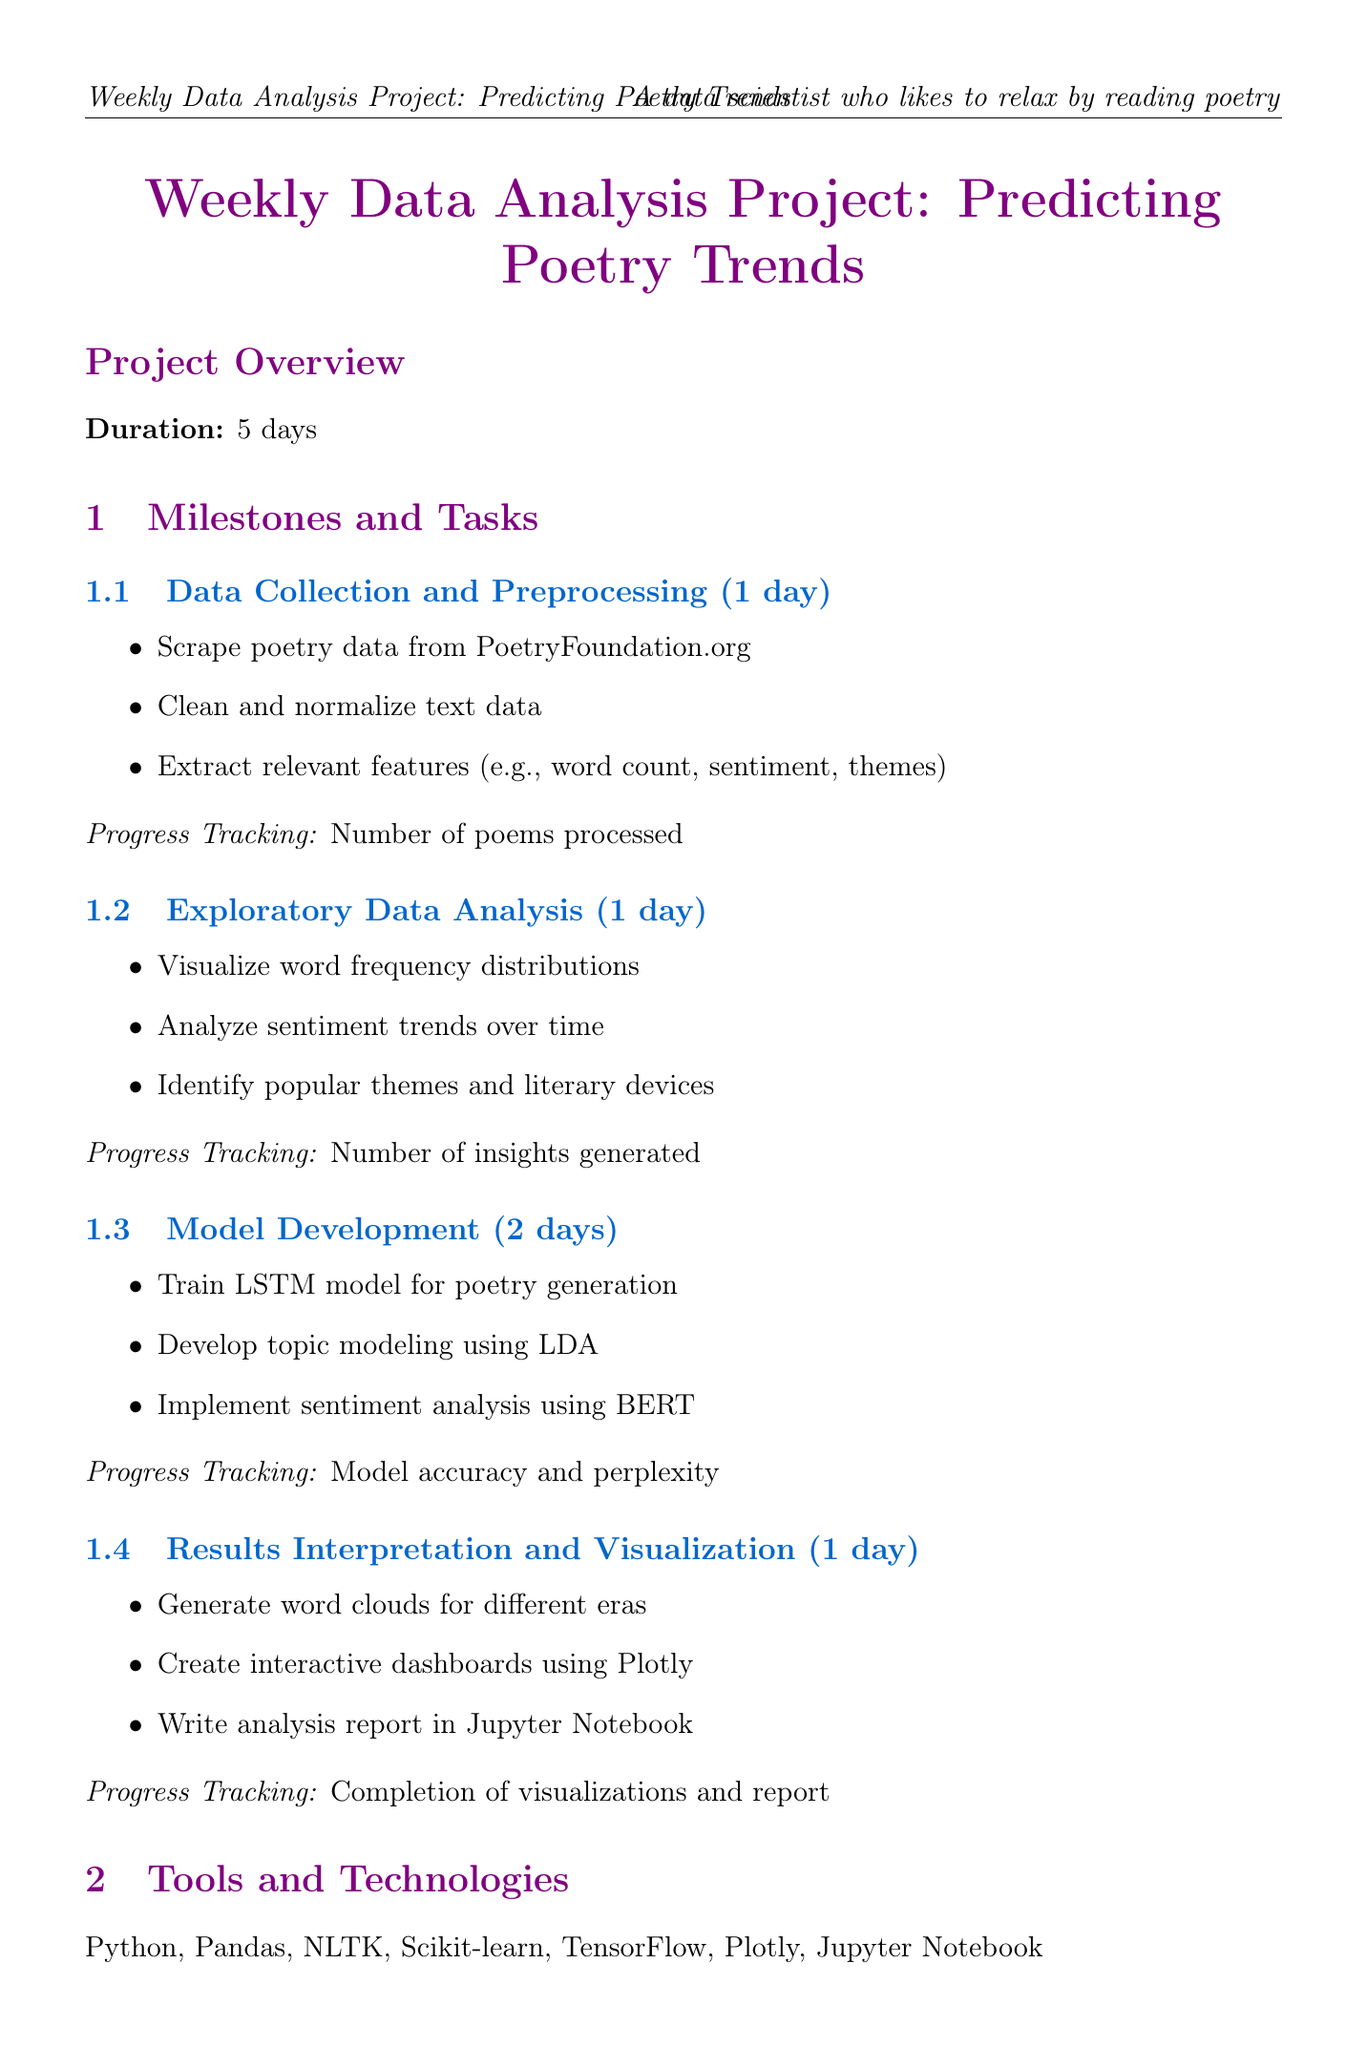What is the project duration? The project duration is specified in the document as 5 days.
Answer: 5 days Who is responsible for model development and poetry analysis? The document lists team members and their responsibilities; Emily Dickinson is assigned to this role.
Answer: Emily Dickinson What is the daily stand-up time? The document explicitly states the daily stand-up time as indicated.
Answer: 9:00 AM How many tasks are listed under Exploratory Data Analysis? The number of tasks in the Exploratory Data Analysis section can be counted from the document.
Answer: 3 tasks What is one potential challenge mentioned in the document? A list of potential challenges is provided, and one can be retrieved as an example.
Answer: Handling archaic language in older poems What technology is used for data visualization? The tools and technologies section lists specific tools; Plotly is mentioned for visualization.
Answer: Plotly How many days are allocated for Model Development? The document specifies the duration for the model development milestone.
Answer: 2 days What deliverable is related to the interactive dashboard? The project deliverables mention an interactive visualization dashboard explicitly.
Answer: Interactive visualization dashboard What is one relaxation activity included in the schedule? The document lists various relaxation activities, one of which can be highlighted.
Answer: Team haiku composition session 